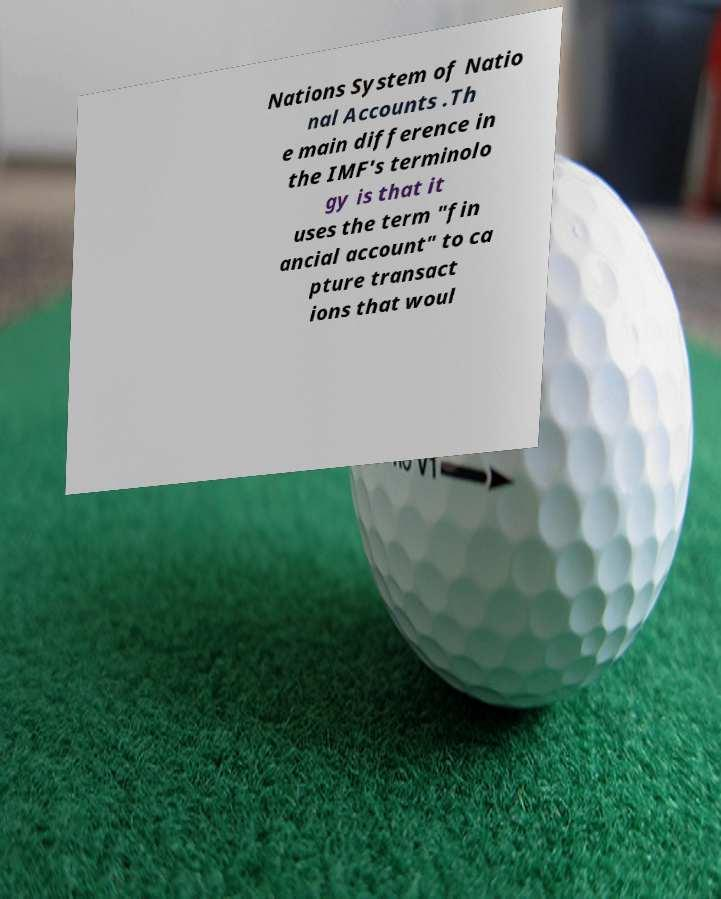There's text embedded in this image that I need extracted. Can you transcribe it verbatim? Nations System of Natio nal Accounts .Th e main difference in the IMF's terminolo gy is that it uses the term "fin ancial account" to ca pture transact ions that woul 